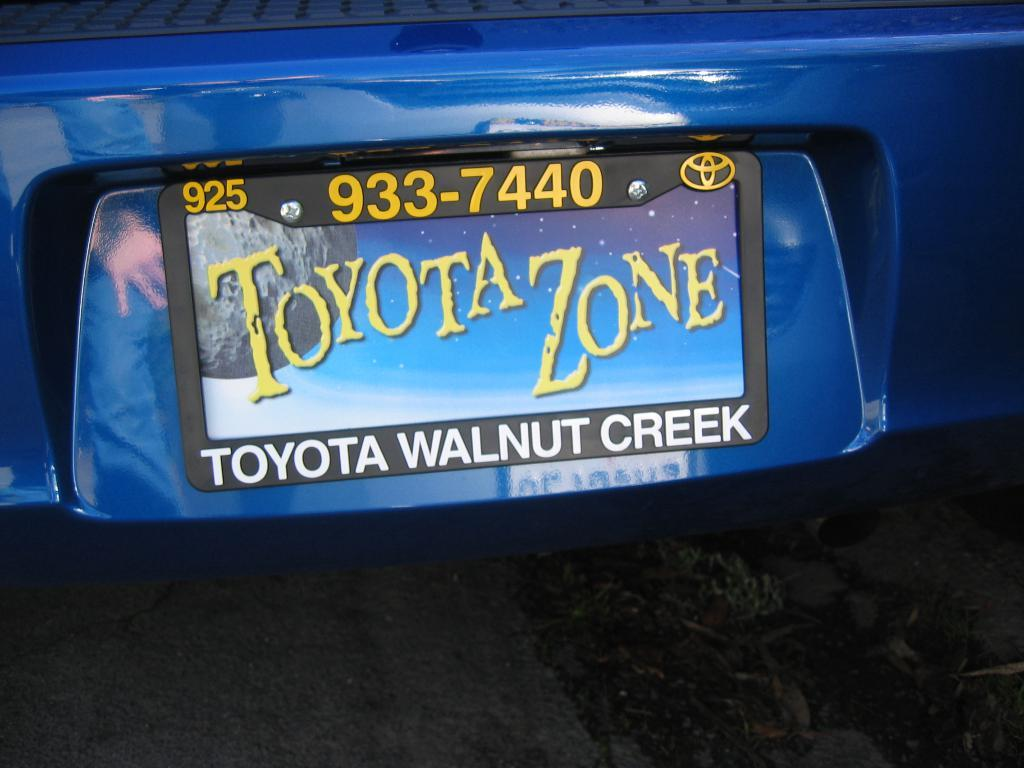<image>
Relay a brief, clear account of the picture shown. Toyota Zone is written in yellow on the blue license plate placard. 